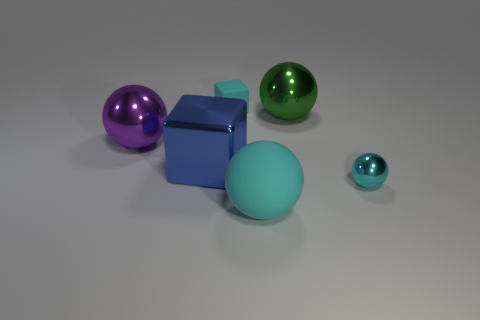There is a small thing that is on the right side of the metallic object behind the big purple shiny ball; what is its color?
Make the answer very short. Cyan. What material is the small thing that is behind the large object left of the cube left of the small cube made of?
Keep it short and to the point. Rubber. What number of green metallic spheres are the same size as the purple metal object?
Keep it short and to the point. 1. There is a cyan object that is in front of the rubber cube and left of the tiny cyan metallic object; what material is it made of?
Ensure brevity in your answer.  Rubber. What number of cyan rubber things are behind the tiny metallic ball?
Make the answer very short. 1. Does the small shiny thing have the same shape as the small cyan thing behind the large block?
Keep it short and to the point. No. Are there any small purple metal things of the same shape as the big purple object?
Your response must be concise. No. There is a cyan thing behind the thing on the left side of the metal block; what is its shape?
Keep it short and to the point. Cube. What is the shape of the small cyan thing that is right of the large cyan sphere?
Give a very brief answer. Sphere. There is a metallic ball in front of the blue metal cube; is it the same color as the big metallic object that is on the right side of the cyan rubber ball?
Provide a short and direct response. No. 